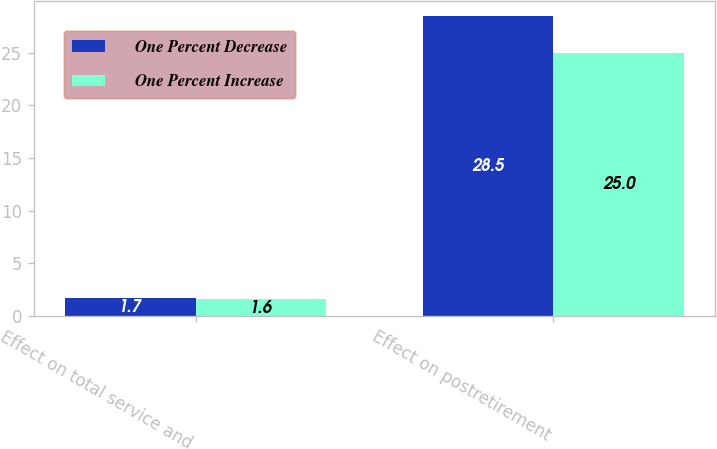Convert chart. <chart><loc_0><loc_0><loc_500><loc_500><stacked_bar_chart><ecel><fcel>Effect on total service and<fcel>Effect on postretirement<nl><fcel>One Percent Decrease<fcel>1.7<fcel>28.5<nl><fcel>One Percent Increase<fcel>1.6<fcel>25<nl></chart> 